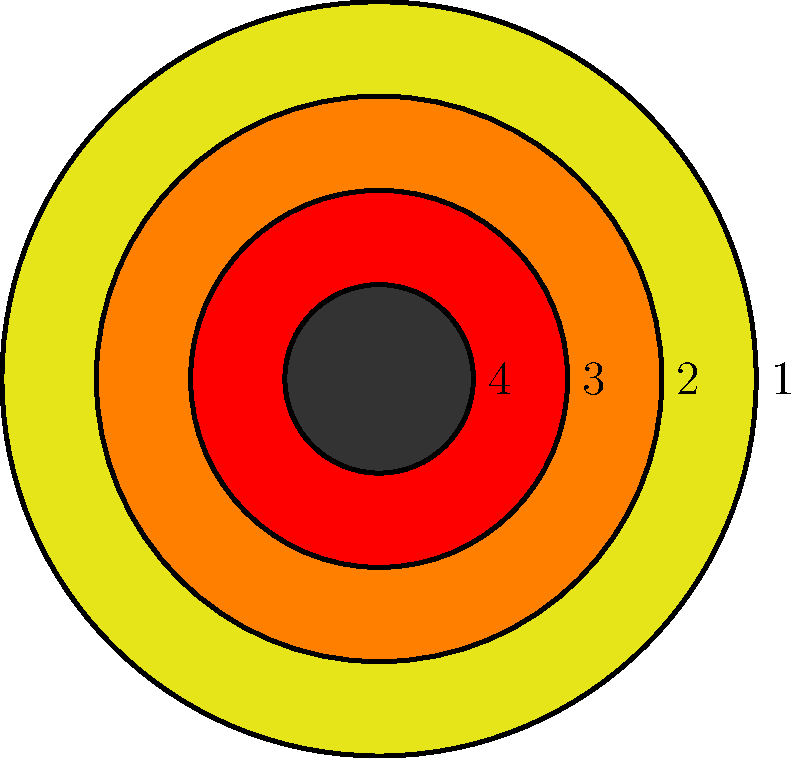In the minimalist representation of a star's lifecycle, which geometric shape corresponds to the Red Giant phase? To answer this question, we need to understand the lifecycle of a star and how it's represented in the minimalist geometric design:

1. The outermost circle (1) represents the initial Main Sequence phase, where the star spends most of its life fusing hydrogen into helium in its core.

2. The second circle (2) represents the Red Giant phase. This occurs when the star has exhausted its core hydrogen. The star expands significantly, becoming cooler and redder, hence the name "Red Giant."

3. The third circle (3) represents the Planetary Nebula phase, where the outer layers of the star are ejected, forming a glowing shell of gas around the star's remnant.

4. The innermost circle (4) represents the final White Dwarf stage, where only the dense core of the star remains.

In this minimalist representation, the Red Giant phase is depicted by the second largest circle, labeled "2". This circle is larger than the star's final stages but smaller than its Main Sequence phase, accurately representing the expansion that occurs during the Red Giant phase.
Answer: Circle 2 